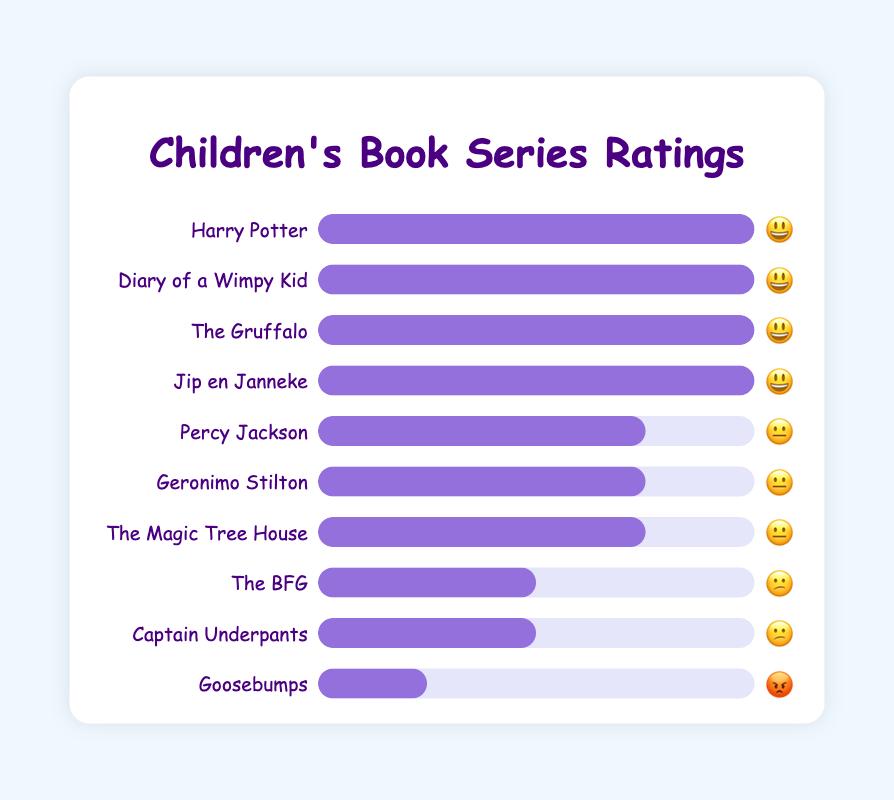Which book series has the highest customer satisfaction rating? All book series with the highest customer satisfaction rating are indicated by the "😃" emoji. According to the figure, "Harry Potter," "Diary of a Wimpy Kid," "The Gruffalo," and "Jip en Janneke" all have the highest rating.
Answer: "Harry Potter," "Diary of a Wimpy Kid," "The Gruffalo," and "Jip en Janneke" Which book series received the lowest customer satisfaction rating? The series with the lowest customer satisfaction rating is indicated by the "😡" emoji. In the figure, "Goosebumps" is the only series with this rating.
Answer: "Goosebumps" How many book series received a "😐" rating? By counting the book series listed with a "😐" rating, we see that there are three: "Percy Jackson," "Geronimo Stilton," and "The Magic Tree House."
Answer: 3 Which book series has a higher rating: "Percy Jackson" or "The BFG"? "Percy Jackson" is rated "😐" while "The BFG" is rated "😕". Since "😐" is a higher rating than "😕," "Percy Jackson" has a higher rating.
Answer: "Percy Jackson" How many book series have a better rating than "The BFG"? "The BFG" is rated "😕." All series rated "😃" and "😐" are better than "😕." Counting these series, we find there are 7 ("Harry Potter," "Diary of a Wimpy Kid," "The Gruffalo," "Jip en Janneke," "Percy Jackson," "Geronimo Stilton," and "The Magic Tree House").
Answer: 7 How many book series are rated "😃"? By counting the book series listed with a "😃" rating, we see that there are four: "Harry Potter," "Diary of a Wimpy Kid," "The Gruffalo," and "Jip en Janneke."
Answer: 4 Compare the number of series rated "😐" to those rated "😕". Which group has more series and by how many? There are three series rated "😐" and two series rated "😕." The group with the "😐" rating has one more series than the group with the "😕" rating.
Answer: "😐" by 1 What is the overall sentiment for the book series in the lower ratings (😕 and 😡)? There are 2 series with the "😕" rating and 1 series with the "😡" rating. In total, this sums up to 3 series with lower ratings, indicating a general sentiment of dissatisfaction for these series.
Answer: Dissatisfaction for 3 series Which book series received an average customer satisfaction rating (😐)? The average rating is indicated by the "😐" emoji. The book series that received this rating are "Percy Jackson," "Geronimo Stilton," and "The Magic Tree House."
Answer: "Percy Jackson," "Geronimo Stilton," "The Magic Tree House" How many more book series received a "😃" rating compared to a "😕" rating? There are four series with a "😃" rating and two series with a "😕" rating. The difference is 4 - 2 = 2, so two more series received a "😃" rating compared to a "😕" rating.
Answer: 2 